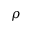<formula> <loc_0><loc_0><loc_500><loc_500>\rho</formula> 